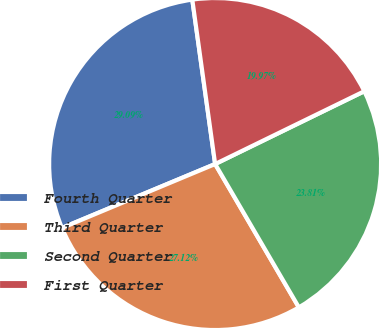Convert chart to OTSL. <chart><loc_0><loc_0><loc_500><loc_500><pie_chart><fcel>Fourth Quarter<fcel>Third Quarter<fcel>Second Quarter<fcel>First Quarter<nl><fcel>29.09%<fcel>27.12%<fcel>23.81%<fcel>19.97%<nl></chart> 